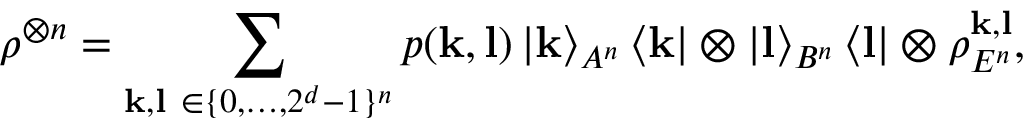<formula> <loc_0><loc_0><loc_500><loc_500>\rho ^ { \otimes n } = \sum _ { k , l \in \{ 0 , \dots , 2 ^ { d } - 1 \} ^ { n } } p ( k , l ) \left | k \right \rangle _ { A ^ { n } } \left \langle k \right | \otimes \left | l \right \rangle _ { B ^ { n } } \left \langle l \right | \otimes \rho _ { E ^ { n } } ^ { k , l } ,</formula> 